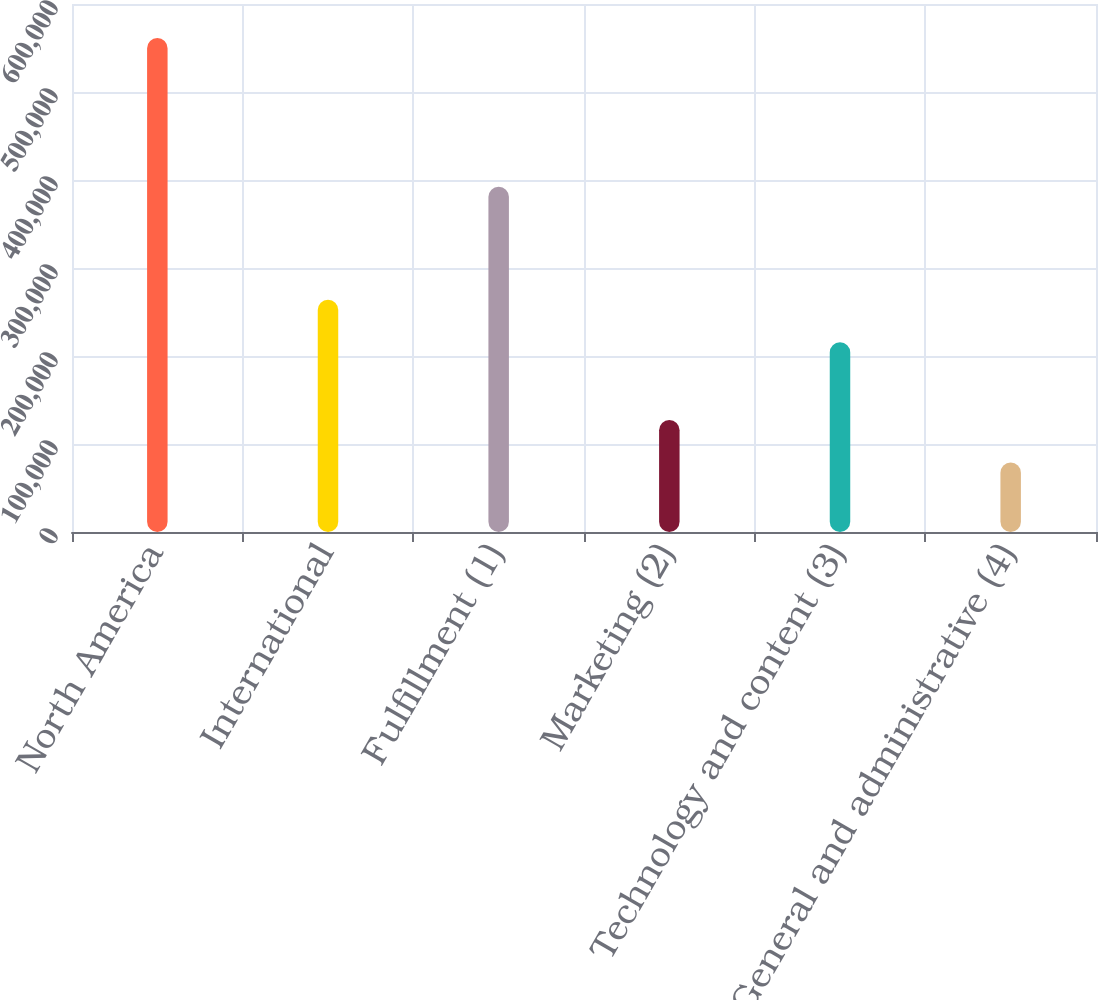<chart> <loc_0><loc_0><loc_500><loc_500><bar_chart><fcel>North America<fcel>International<fcel>Fulfillment (1)<fcel>Marketing (2)<fcel>Technology and content (3)<fcel>General and administrative (4)<nl><fcel>561318<fcel>263844<fcel>392467<fcel>127276<fcel>215617<fcel>79049<nl></chart> 